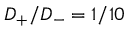<formula> <loc_0><loc_0><loc_500><loc_500>D _ { + } / D _ { - } = 1 / 1 0</formula> 